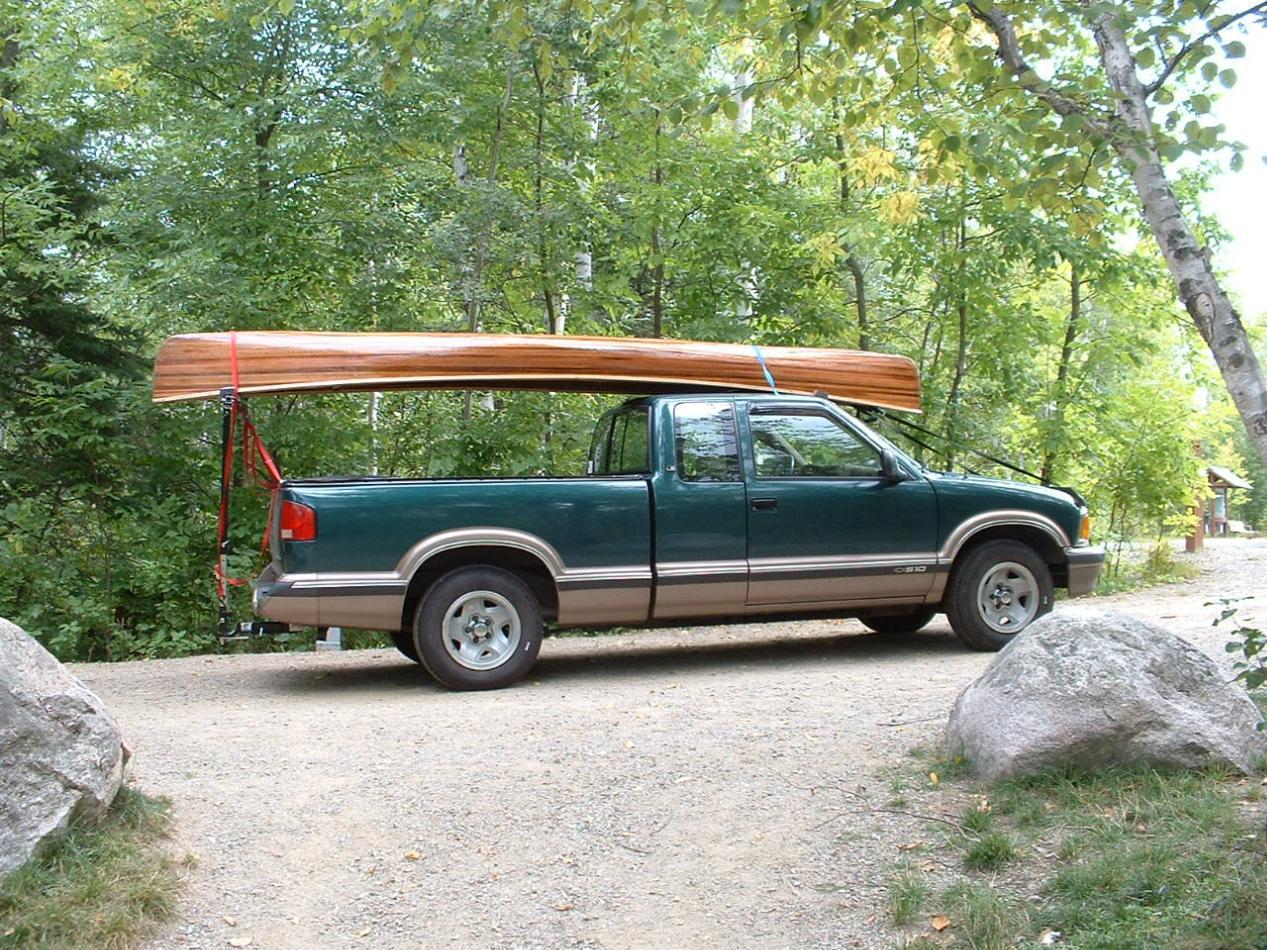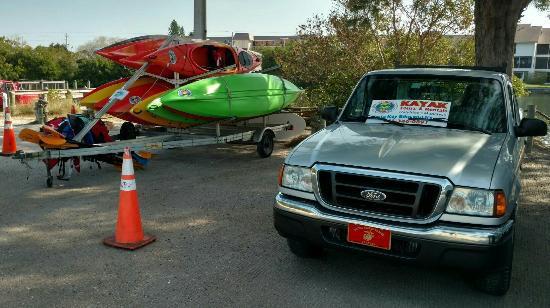The first image is the image on the left, the second image is the image on the right. Examine the images to the left and right. Is the description "The left image contains one red truck." accurate? Answer yes or no. No. The first image is the image on the left, the second image is the image on the right. Considering the images on both sides, is "In one image, a pickup truck near a body of water has one canoe loaded on a roof rack, while a second image shows a pickup truck near a green woody area with two canoes loaded overhead." valid? Answer yes or no. No. 